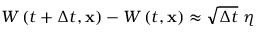Convert formula to latex. <formula><loc_0><loc_0><loc_500><loc_500>W \left ( t + \Delta t , x \right ) - W \left ( t , x \right ) \approx \sqrt { \Delta t } \ \eta</formula> 